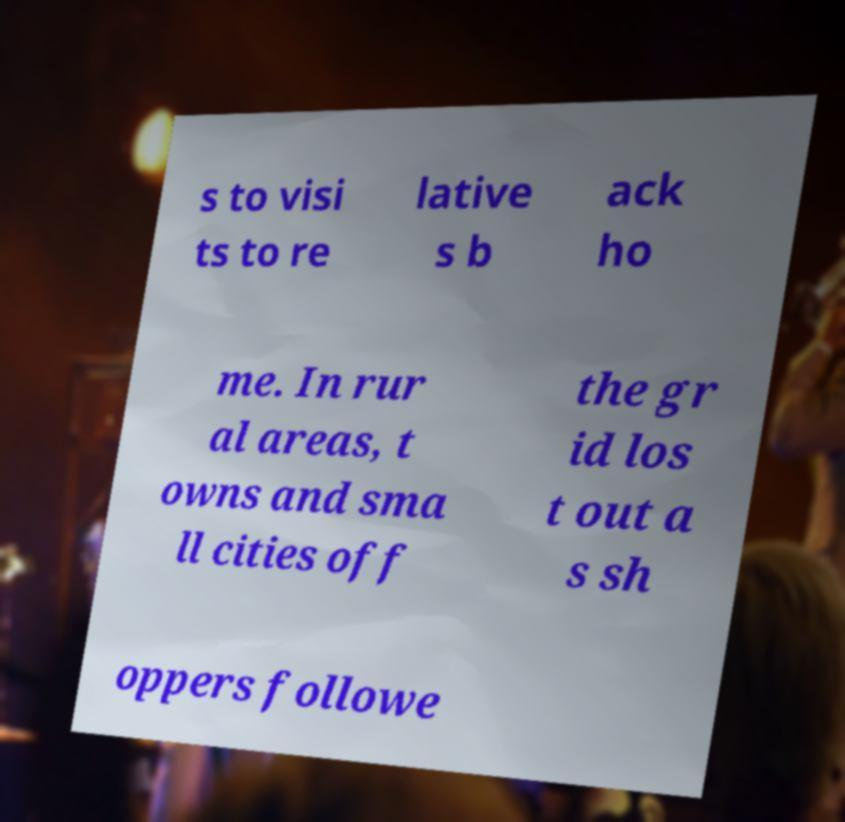I need the written content from this picture converted into text. Can you do that? s to visi ts to re lative s b ack ho me. In rur al areas, t owns and sma ll cities off the gr id los t out a s sh oppers followe 